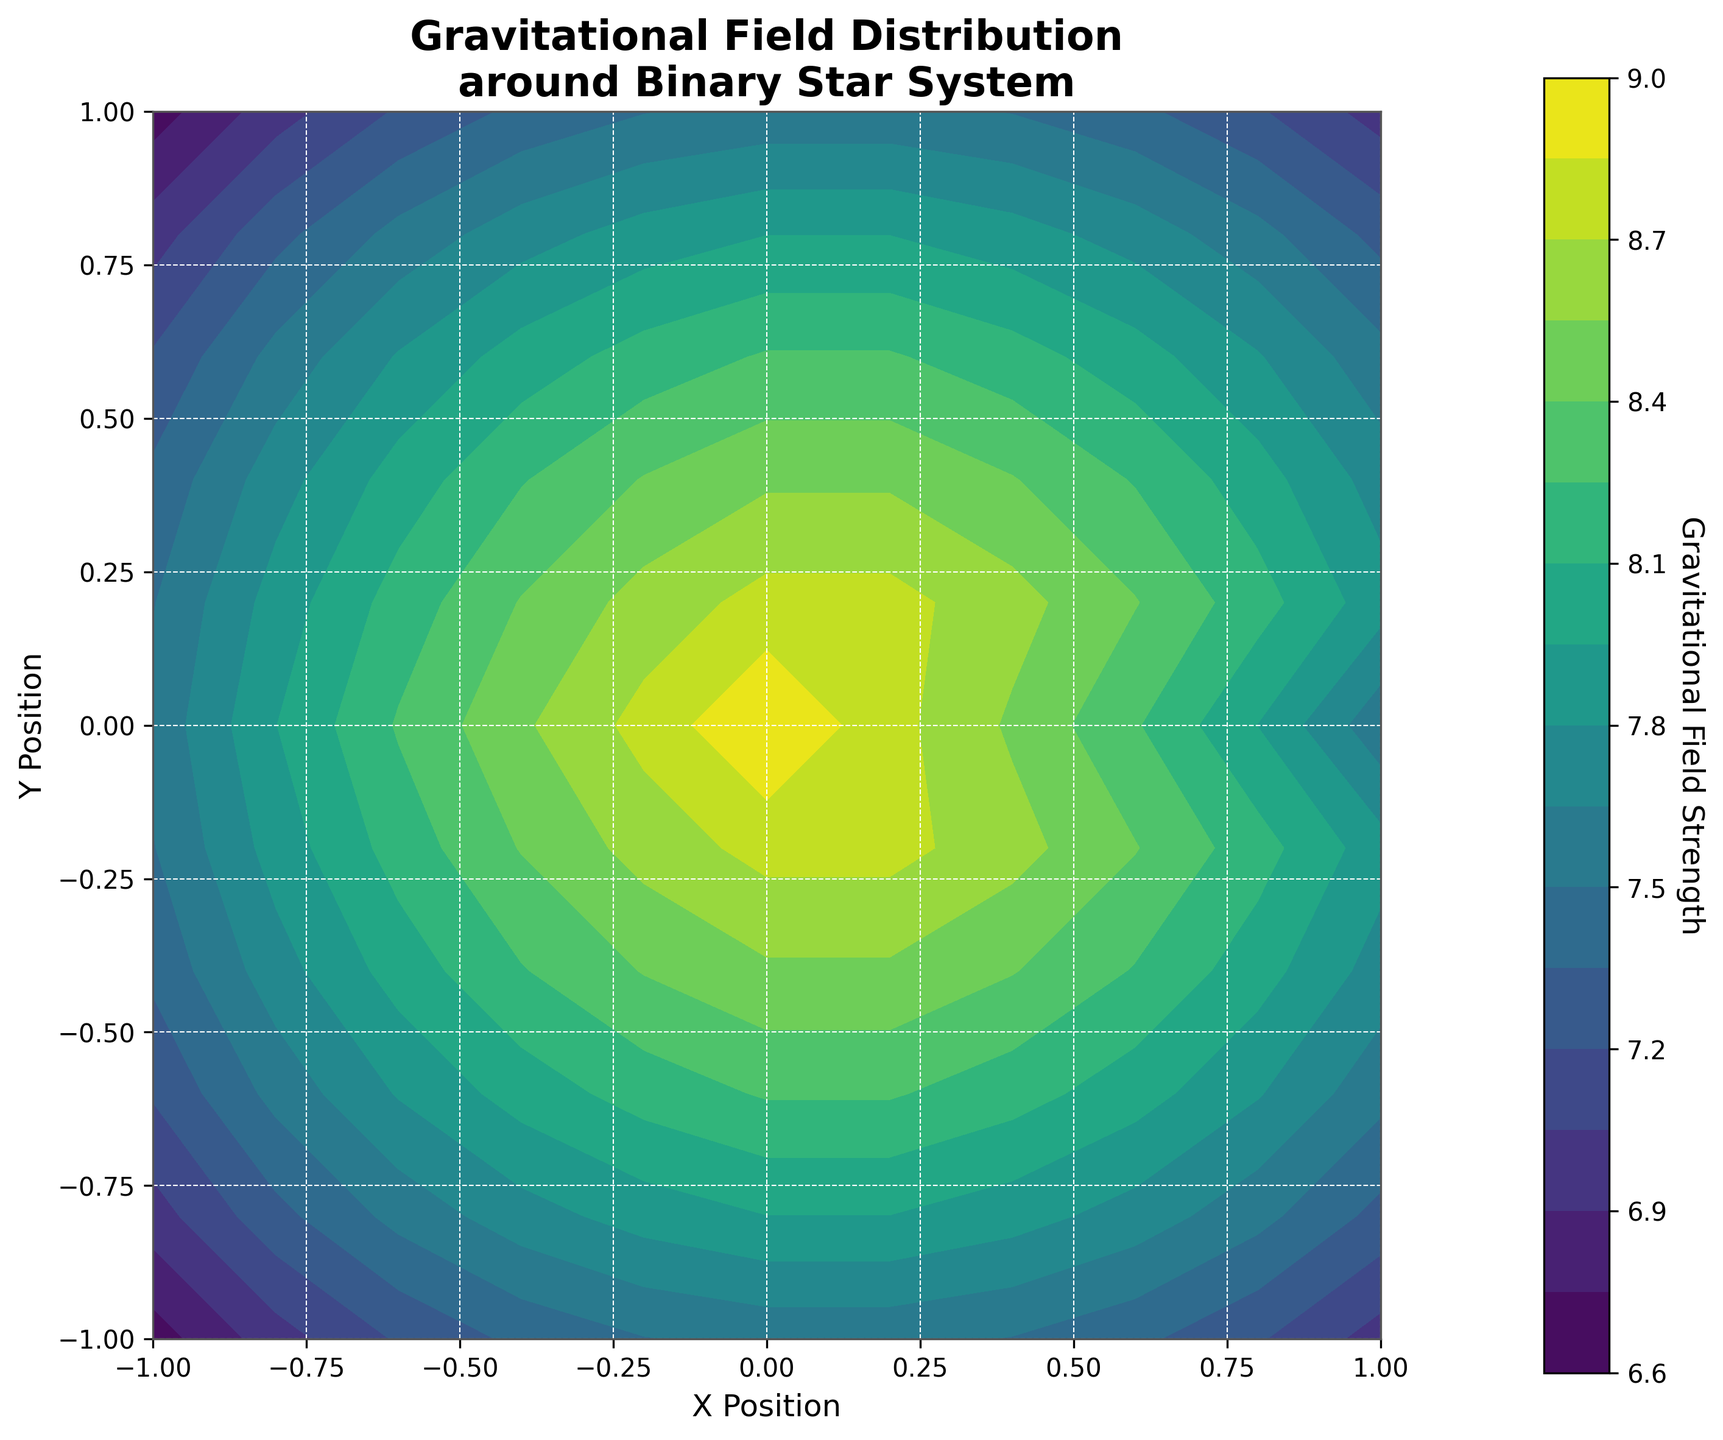What's the title of the plot? The title of the plot is displayed at the top and typically provides a summary of what the plot represents. Here, it states the distribution of gravitational fields around a binary star system.
Answer: Gravitational Field Distribution around Binary Star System What is the color used for the highest gravitational field strength in the plot? By looking at the color bar on the right-hand side, you can identify the colors associated with various gravitational field strengths. The highest gravitational field strength corresponds to the color at the top end of the color bar.
Answer: Yellow In which region of the plot is the gravitational field strength the highest? The region with the highest gravitational field is indicated by the brightest color, typically near the center where the field strength values are highest. Identify the corresponding coordinates in this region.
Answer: Around the origin (0, 0) Do the gravitational field strengths increase or decrease as you move away from the center? Observe the color gradient from the center towards the edges. Darker colors towards the edges suggest a decrease in gravitational field strength as you move away from the center.
Answer: Decrease Where on the plot do you find the lowest values of gravitational field strength? The post with the lowest gravitational field strength is indicated by the darkest colors, typically found at the corners of the plot. Look at the corresponding x and y values in these areas.
Answer: At the corners Is there symmetry in the gravitational field distribution? If so, describe the symmetry. Observe the overall shape and color distribution. The plot shows an equal gradient and contours radiating outward from the center, indicating a symmetric gravitational field.
Answer: Symmetry around both x and y axes How does the gravitational field strength compare at (1,1) and (-1,-1)? Locate the points (1,1) and (-1,-1) on the plot and compare the colors corresponding to their gravitational field strengths. Both points fall in regions with similar colors, indicating similar gravitational field strengths.
Answer: Similar What is the approximate gravitational field strength at the coordinates (0.2, 0.2)? Find the coordinates (0.2, 0.2) on the plot, then look at the corresponding contour color and the color bar to estimate the value.
Answer: Around 8.754 What can you infer about the gravitational field strength along the x-axis at y=0? Observe the color changes along the x-axis at y=0, noting how the gravitational field strength varies. It peaks at the center (zero) and decreases symmetrically on both sides.
Answer: Peaks at 0, decreases symmetrically 